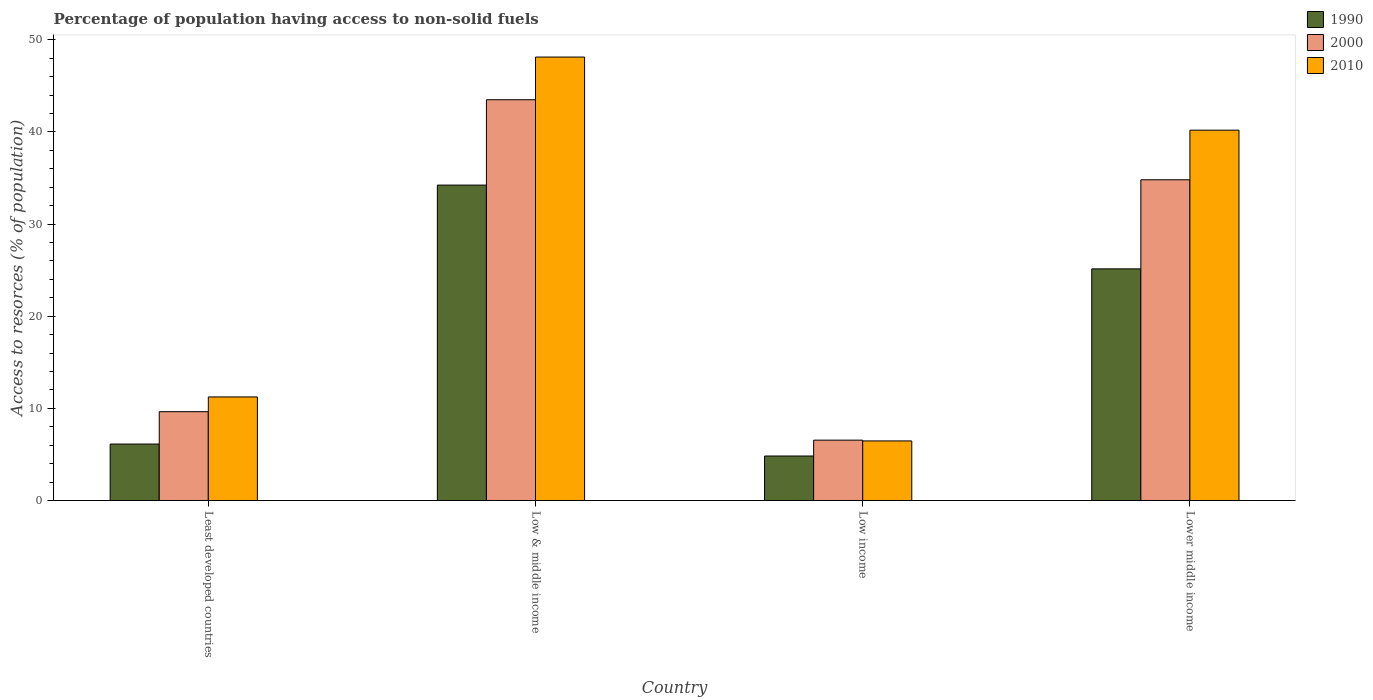How many different coloured bars are there?
Offer a terse response. 3. How many groups of bars are there?
Keep it short and to the point. 4. What is the label of the 4th group of bars from the left?
Provide a succinct answer. Lower middle income. What is the percentage of population having access to non-solid fuels in 2010 in Lower middle income?
Give a very brief answer. 40.2. Across all countries, what is the maximum percentage of population having access to non-solid fuels in 2000?
Make the answer very short. 43.5. Across all countries, what is the minimum percentage of population having access to non-solid fuels in 1990?
Make the answer very short. 4.83. In which country was the percentage of population having access to non-solid fuels in 2000 maximum?
Offer a terse response. Low & middle income. What is the total percentage of population having access to non-solid fuels in 2000 in the graph?
Offer a terse response. 94.5. What is the difference between the percentage of population having access to non-solid fuels in 2010 in Low income and that in Lower middle income?
Provide a succinct answer. -33.73. What is the difference between the percentage of population having access to non-solid fuels in 2010 in Low income and the percentage of population having access to non-solid fuels in 1990 in Least developed countries?
Ensure brevity in your answer.  0.34. What is the average percentage of population having access to non-solid fuels in 2000 per country?
Your answer should be very brief. 23.62. What is the difference between the percentage of population having access to non-solid fuels of/in 1990 and percentage of population having access to non-solid fuels of/in 2010 in Lower middle income?
Make the answer very short. -15.06. In how many countries, is the percentage of population having access to non-solid fuels in 2000 greater than 42 %?
Your response must be concise. 1. What is the ratio of the percentage of population having access to non-solid fuels in 2010 in Low & middle income to that in Lower middle income?
Offer a terse response. 1.2. Is the percentage of population having access to non-solid fuels in 2010 in Least developed countries less than that in Lower middle income?
Your answer should be very brief. Yes. Is the difference between the percentage of population having access to non-solid fuels in 1990 in Least developed countries and Lower middle income greater than the difference between the percentage of population having access to non-solid fuels in 2010 in Least developed countries and Lower middle income?
Provide a succinct answer. Yes. What is the difference between the highest and the second highest percentage of population having access to non-solid fuels in 2010?
Make the answer very short. 7.94. What is the difference between the highest and the lowest percentage of population having access to non-solid fuels in 1990?
Ensure brevity in your answer.  29.41. Is the sum of the percentage of population having access to non-solid fuels in 2010 in Low & middle income and Low income greater than the maximum percentage of population having access to non-solid fuels in 2000 across all countries?
Your answer should be very brief. Yes. How many bars are there?
Ensure brevity in your answer.  12. What is the difference between two consecutive major ticks on the Y-axis?
Your answer should be very brief. 10. Does the graph contain any zero values?
Make the answer very short. No. Where does the legend appear in the graph?
Ensure brevity in your answer.  Top right. How are the legend labels stacked?
Your answer should be very brief. Vertical. What is the title of the graph?
Keep it short and to the point. Percentage of population having access to non-solid fuels. What is the label or title of the X-axis?
Provide a succinct answer. Country. What is the label or title of the Y-axis?
Ensure brevity in your answer.  Access to resorces (% of population). What is the Access to resorces (% of population) in 1990 in Least developed countries?
Provide a short and direct response. 6.13. What is the Access to resorces (% of population) of 2000 in Least developed countries?
Keep it short and to the point. 9.64. What is the Access to resorces (% of population) of 2010 in Least developed countries?
Provide a succinct answer. 11.24. What is the Access to resorces (% of population) in 1990 in Low & middle income?
Your answer should be compact. 34.23. What is the Access to resorces (% of population) of 2000 in Low & middle income?
Your answer should be very brief. 43.5. What is the Access to resorces (% of population) of 2010 in Low & middle income?
Make the answer very short. 48.13. What is the Access to resorces (% of population) in 1990 in Low income?
Offer a terse response. 4.83. What is the Access to resorces (% of population) in 2000 in Low income?
Your answer should be very brief. 6.55. What is the Access to resorces (% of population) of 2010 in Low income?
Offer a very short reply. 6.46. What is the Access to resorces (% of population) of 1990 in Lower middle income?
Your response must be concise. 25.14. What is the Access to resorces (% of population) in 2000 in Lower middle income?
Provide a succinct answer. 34.81. What is the Access to resorces (% of population) of 2010 in Lower middle income?
Offer a very short reply. 40.2. Across all countries, what is the maximum Access to resorces (% of population) in 1990?
Your answer should be very brief. 34.23. Across all countries, what is the maximum Access to resorces (% of population) of 2000?
Provide a succinct answer. 43.5. Across all countries, what is the maximum Access to resorces (% of population) of 2010?
Your response must be concise. 48.13. Across all countries, what is the minimum Access to resorces (% of population) of 1990?
Provide a succinct answer. 4.83. Across all countries, what is the minimum Access to resorces (% of population) in 2000?
Ensure brevity in your answer.  6.55. Across all countries, what is the minimum Access to resorces (% of population) of 2010?
Offer a terse response. 6.46. What is the total Access to resorces (% of population) in 1990 in the graph?
Your answer should be very brief. 70.33. What is the total Access to resorces (% of population) of 2000 in the graph?
Give a very brief answer. 94.5. What is the total Access to resorces (% of population) of 2010 in the graph?
Offer a very short reply. 106.03. What is the difference between the Access to resorces (% of population) in 1990 in Least developed countries and that in Low & middle income?
Your response must be concise. -28.11. What is the difference between the Access to resorces (% of population) of 2000 in Least developed countries and that in Low & middle income?
Ensure brevity in your answer.  -33.86. What is the difference between the Access to resorces (% of population) in 2010 in Least developed countries and that in Low & middle income?
Your response must be concise. -36.89. What is the difference between the Access to resorces (% of population) in 1990 in Least developed countries and that in Low income?
Your response must be concise. 1.3. What is the difference between the Access to resorces (% of population) in 2000 in Least developed countries and that in Low income?
Your response must be concise. 3.09. What is the difference between the Access to resorces (% of population) in 2010 in Least developed countries and that in Low income?
Offer a terse response. 4.78. What is the difference between the Access to resorces (% of population) of 1990 in Least developed countries and that in Lower middle income?
Your response must be concise. -19.01. What is the difference between the Access to resorces (% of population) in 2000 in Least developed countries and that in Lower middle income?
Ensure brevity in your answer.  -25.17. What is the difference between the Access to resorces (% of population) in 2010 in Least developed countries and that in Lower middle income?
Give a very brief answer. -28.96. What is the difference between the Access to resorces (% of population) in 1990 in Low & middle income and that in Low income?
Your response must be concise. 29.41. What is the difference between the Access to resorces (% of population) in 2000 in Low & middle income and that in Low income?
Your answer should be compact. 36.95. What is the difference between the Access to resorces (% of population) of 2010 in Low & middle income and that in Low income?
Provide a short and direct response. 41.67. What is the difference between the Access to resorces (% of population) of 1990 in Low & middle income and that in Lower middle income?
Ensure brevity in your answer.  9.09. What is the difference between the Access to resorces (% of population) in 2000 in Low & middle income and that in Lower middle income?
Keep it short and to the point. 8.69. What is the difference between the Access to resorces (% of population) in 2010 in Low & middle income and that in Lower middle income?
Keep it short and to the point. 7.94. What is the difference between the Access to resorces (% of population) of 1990 in Low income and that in Lower middle income?
Make the answer very short. -20.31. What is the difference between the Access to resorces (% of population) of 2000 in Low income and that in Lower middle income?
Your answer should be compact. -28.26. What is the difference between the Access to resorces (% of population) in 2010 in Low income and that in Lower middle income?
Your response must be concise. -33.73. What is the difference between the Access to resorces (% of population) of 1990 in Least developed countries and the Access to resorces (% of population) of 2000 in Low & middle income?
Offer a very short reply. -37.37. What is the difference between the Access to resorces (% of population) of 1990 in Least developed countries and the Access to resorces (% of population) of 2010 in Low & middle income?
Offer a very short reply. -42.01. What is the difference between the Access to resorces (% of population) in 2000 in Least developed countries and the Access to resorces (% of population) in 2010 in Low & middle income?
Your response must be concise. -38.49. What is the difference between the Access to resorces (% of population) in 1990 in Least developed countries and the Access to resorces (% of population) in 2000 in Low income?
Offer a terse response. -0.42. What is the difference between the Access to resorces (% of population) in 1990 in Least developed countries and the Access to resorces (% of population) in 2010 in Low income?
Keep it short and to the point. -0.34. What is the difference between the Access to resorces (% of population) in 2000 in Least developed countries and the Access to resorces (% of population) in 2010 in Low income?
Ensure brevity in your answer.  3.18. What is the difference between the Access to resorces (% of population) of 1990 in Least developed countries and the Access to resorces (% of population) of 2000 in Lower middle income?
Offer a very short reply. -28.68. What is the difference between the Access to resorces (% of population) of 1990 in Least developed countries and the Access to resorces (% of population) of 2010 in Lower middle income?
Your answer should be compact. -34.07. What is the difference between the Access to resorces (% of population) of 2000 in Least developed countries and the Access to resorces (% of population) of 2010 in Lower middle income?
Give a very brief answer. -30.56. What is the difference between the Access to resorces (% of population) of 1990 in Low & middle income and the Access to resorces (% of population) of 2000 in Low income?
Ensure brevity in your answer.  27.68. What is the difference between the Access to resorces (% of population) of 1990 in Low & middle income and the Access to resorces (% of population) of 2010 in Low income?
Offer a very short reply. 27.77. What is the difference between the Access to resorces (% of population) in 2000 in Low & middle income and the Access to resorces (% of population) in 2010 in Low income?
Your response must be concise. 37.04. What is the difference between the Access to resorces (% of population) in 1990 in Low & middle income and the Access to resorces (% of population) in 2000 in Lower middle income?
Your answer should be compact. -0.58. What is the difference between the Access to resorces (% of population) in 1990 in Low & middle income and the Access to resorces (% of population) in 2010 in Lower middle income?
Keep it short and to the point. -5.96. What is the difference between the Access to resorces (% of population) of 2000 in Low & middle income and the Access to resorces (% of population) of 2010 in Lower middle income?
Ensure brevity in your answer.  3.3. What is the difference between the Access to resorces (% of population) in 1990 in Low income and the Access to resorces (% of population) in 2000 in Lower middle income?
Your answer should be compact. -29.98. What is the difference between the Access to resorces (% of population) of 1990 in Low income and the Access to resorces (% of population) of 2010 in Lower middle income?
Your answer should be very brief. -35.37. What is the difference between the Access to resorces (% of population) of 2000 in Low income and the Access to resorces (% of population) of 2010 in Lower middle income?
Ensure brevity in your answer.  -33.65. What is the average Access to resorces (% of population) in 1990 per country?
Make the answer very short. 17.58. What is the average Access to resorces (% of population) in 2000 per country?
Your response must be concise. 23.62. What is the average Access to resorces (% of population) in 2010 per country?
Keep it short and to the point. 26.51. What is the difference between the Access to resorces (% of population) of 1990 and Access to resorces (% of population) of 2000 in Least developed countries?
Keep it short and to the point. -3.51. What is the difference between the Access to resorces (% of population) of 1990 and Access to resorces (% of population) of 2010 in Least developed countries?
Provide a succinct answer. -5.11. What is the difference between the Access to resorces (% of population) of 2000 and Access to resorces (% of population) of 2010 in Least developed countries?
Provide a short and direct response. -1.6. What is the difference between the Access to resorces (% of population) of 1990 and Access to resorces (% of population) of 2000 in Low & middle income?
Keep it short and to the point. -9.26. What is the difference between the Access to resorces (% of population) of 1990 and Access to resorces (% of population) of 2010 in Low & middle income?
Your answer should be compact. -13.9. What is the difference between the Access to resorces (% of population) in 2000 and Access to resorces (% of population) in 2010 in Low & middle income?
Ensure brevity in your answer.  -4.63. What is the difference between the Access to resorces (% of population) of 1990 and Access to resorces (% of population) of 2000 in Low income?
Your response must be concise. -1.72. What is the difference between the Access to resorces (% of population) of 1990 and Access to resorces (% of population) of 2010 in Low income?
Give a very brief answer. -1.64. What is the difference between the Access to resorces (% of population) in 2000 and Access to resorces (% of population) in 2010 in Low income?
Provide a succinct answer. 0.09. What is the difference between the Access to resorces (% of population) in 1990 and Access to resorces (% of population) in 2000 in Lower middle income?
Your answer should be very brief. -9.67. What is the difference between the Access to resorces (% of population) in 1990 and Access to resorces (% of population) in 2010 in Lower middle income?
Your answer should be very brief. -15.06. What is the difference between the Access to resorces (% of population) of 2000 and Access to resorces (% of population) of 2010 in Lower middle income?
Offer a terse response. -5.39. What is the ratio of the Access to resorces (% of population) of 1990 in Least developed countries to that in Low & middle income?
Your answer should be compact. 0.18. What is the ratio of the Access to resorces (% of population) of 2000 in Least developed countries to that in Low & middle income?
Give a very brief answer. 0.22. What is the ratio of the Access to resorces (% of population) of 2010 in Least developed countries to that in Low & middle income?
Keep it short and to the point. 0.23. What is the ratio of the Access to resorces (% of population) in 1990 in Least developed countries to that in Low income?
Keep it short and to the point. 1.27. What is the ratio of the Access to resorces (% of population) of 2000 in Least developed countries to that in Low income?
Your response must be concise. 1.47. What is the ratio of the Access to resorces (% of population) of 2010 in Least developed countries to that in Low income?
Your answer should be compact. 1.74. What is the ratio of the Access to resorces (% of population) of 1990 in Least developed countries to that in Lower middle income?
Make the answer very short. 0.24. What is the ratio of the Access to resorces (% of population) of 2000 in Least developed countries to that in Lower middle income?
Your response must be concise. 0.28. What is the ratio of the Access to resorces (% of population) in 2010 in Least developed countries to that in Lower middle income?
Provide a short and direct response. 0.28. What is the ratio of the Access to resorces (% of population) of 1990 in Low & middle income to that in Low income?
Offer a terse response. 7.09. What is the ratio of the Access to resorces (% of population) in 2000 in Low & middle income to that in Low income?
Provide a succinct answer. 6.64. What is the ratio of the Access to resorces (% of population) of 2010 in Low & middle income to that in Low income?
Provide a short and direct response. 7.45. What is the ratio of the Access to resorces (% of population) in 1990 in Low & middle income to that in Lower middle income?
Make the answer very short. 1.36. What is the ratio of the Access to resorces (% of population) in 2000 in Low & middle income to that in Lower middle income?
Provide a short and direct response. 1.25. What is the ratio of the Access to resorces (% of population) of 2010 in Low & middle income to that in Lower middle income?
Ensure brevity in your answer.  1.2. What is the ratio of the Access to resorces (% of population) of 1990 in Low income to that in Lower middle income?
Provide a succinct answer. 0.19. What is the ratio of the Access to resorces (% of population) of 2000 in Low income to that in Lower middle income?
Make the answer very short. 0.19. What is the ratio of the Access to resorces (% of population) of 2010 in Low income to that in Lower middle income?
Provide a succinct answer. 0.16. What is the difference between the highest and the second highest Access to resorces (% of population) in 1990?
Ensure brevity in your answer.  9.09. What is the difference between the highest and the second highest Access to resorces (% of population) in 2000?
Provide a short and direct response. 8.69. What is the difference between the highest and the second highest Access to resorces (% of population) in 2010?
Your answer should be very brief. 7.94. What is the difference between the highest and the lowest Access to resorces (% of population) of 1990?
Make the answer very short. 29.41. What is the difference between the highest and the lowest Access to resorces (% of population) in 2000?
Offer a terse response. 36.95. What is the difference between the highest and the lowest Access to resorces (% of population) of 2010?
Keep it short and to the point. 41.67. 